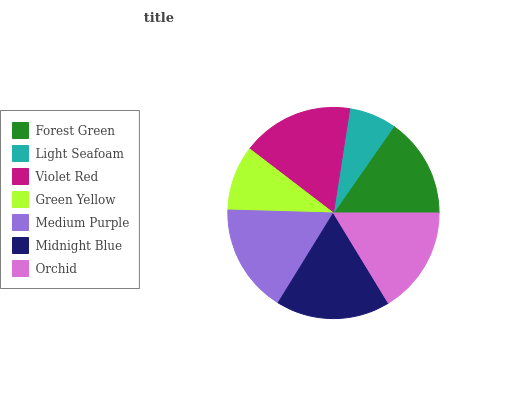Is Light Seafoam the minimum?
Answer yes or no. Yes. Is Midnight Blue the maximum?
Answer yes or no. Yes. Is Violet Red the minimum?
Answer yes or no. No. Is Violet Red the maximum?
Answer yes or no. No. Is Violet Red greater than Light Seafoam?
Answer yes or no. Yes. Is Light Seafoam less than Violet Red?
Answer yes or no. Yes. Is Light Seafoam greater than Violet Red?
Answer yes or no. No. Is Violet Red less than Light Seafoam?
Answer yes or no. No. Is Orchid the high median?
Answer yes or no. Yes. Is Orchid the low median?
Answer yes or no. Yes. Is Midnight Blue the high median?
Answer yes or no. No. Is Forest Green the low median?
Answer yes or no. No. 